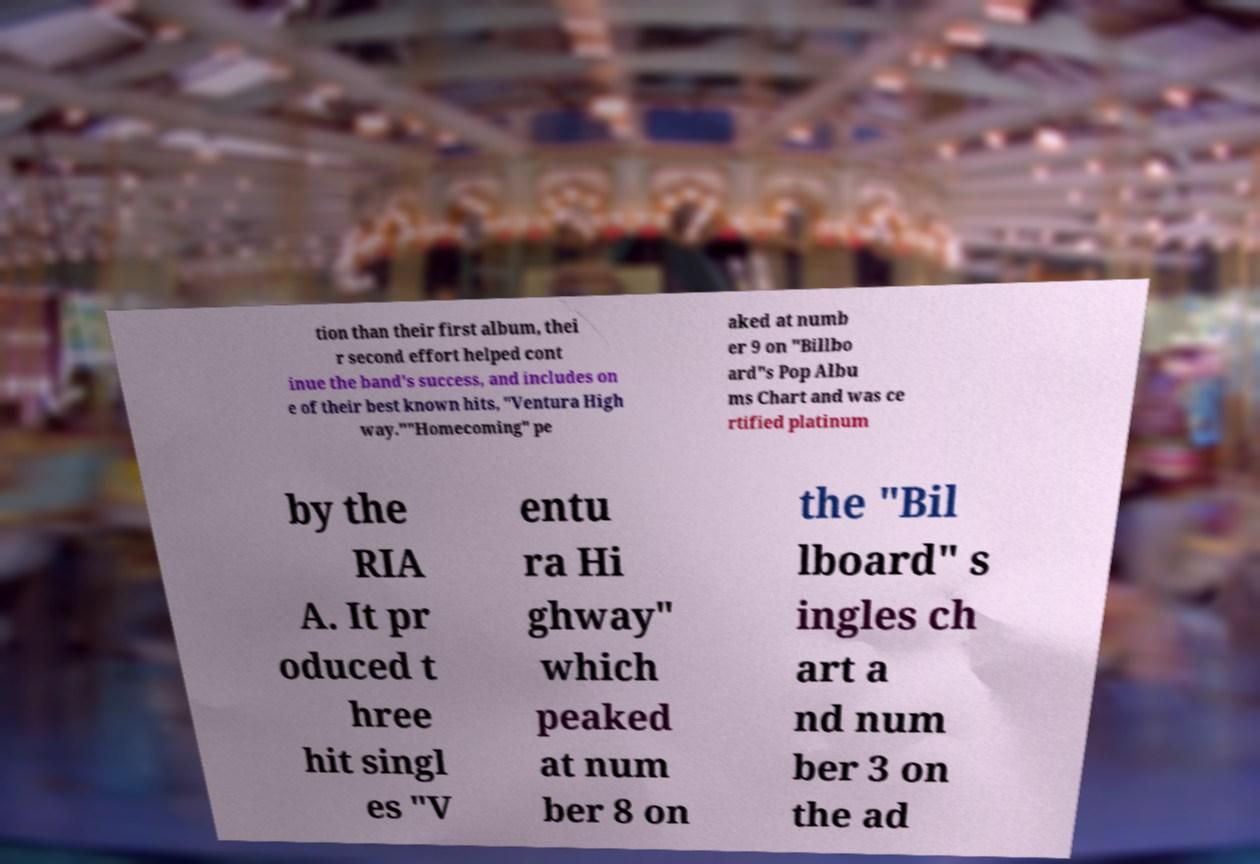Could you extract and type out the text from this image? tion than their first album, thei r second effort helped cont inue the band's success, and includes on e of their best known hits, "Ventura High way.""Homecoming" pe aked at numb er 9 on "Billbo ard"s Pop Albu ms Chart and was ce rtified platinum by the RIA A. It pr oduced t hree hit singl es "V entu ra Hi ghway" which peaked at num ber 8 on the "Bil lboard" s ingles ch art a nd num ber 3 on the ad 